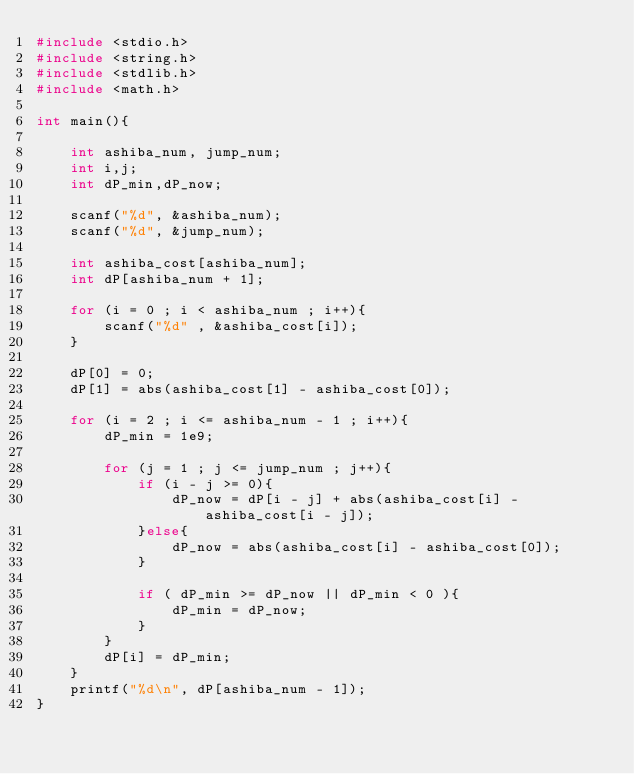Convert code to text. <code><loc_0><loc_0><loc_500><loc_500><_C_>#include <stdio.h>
#include <string.h>
#include <stdlib.h>
#include <math.h>

int main(){

    int ashiba_num, jump_num;
    int i,j;
    int dP_min,dP_now;

    scanf("%d", &ashiba_num);
    scanf("%d", &jump_num);

    int ashiba_cost[ashiba_num];
    int dP[ashiba_num + 1];

    for (i = 0 ; i < ashiba_num ; i++){
        scanf("%d" , &ashiba_cost[i]);         
    }

    dP[0] = 0;
    dP[1] = abs(ashiba_cost[1] - ashiba_cost[0]);

    for (i = 2 ; i <= ashiba_num - 1 ; i++){
        dP_min = 1e9;

        for (j = 1 ; j <= jump_num ; j++){
            if (i - j >= 0){
                dP_now = dP[i - j] + abs(ashiba_cost[i] - ashiba_cost[i - j]);
            }else{
                dP_now = abs(ashiba_cost[i] - ashiba_cost[0]);
            }

            if ( dP_min >= dP_now || dP_min < 0 ){
                dP_min = dP_now;
            }
        }
        dP[i] = dP_min;
    }
    printf("%d\n", dP[ashiba_num - 1]);
}</code> 